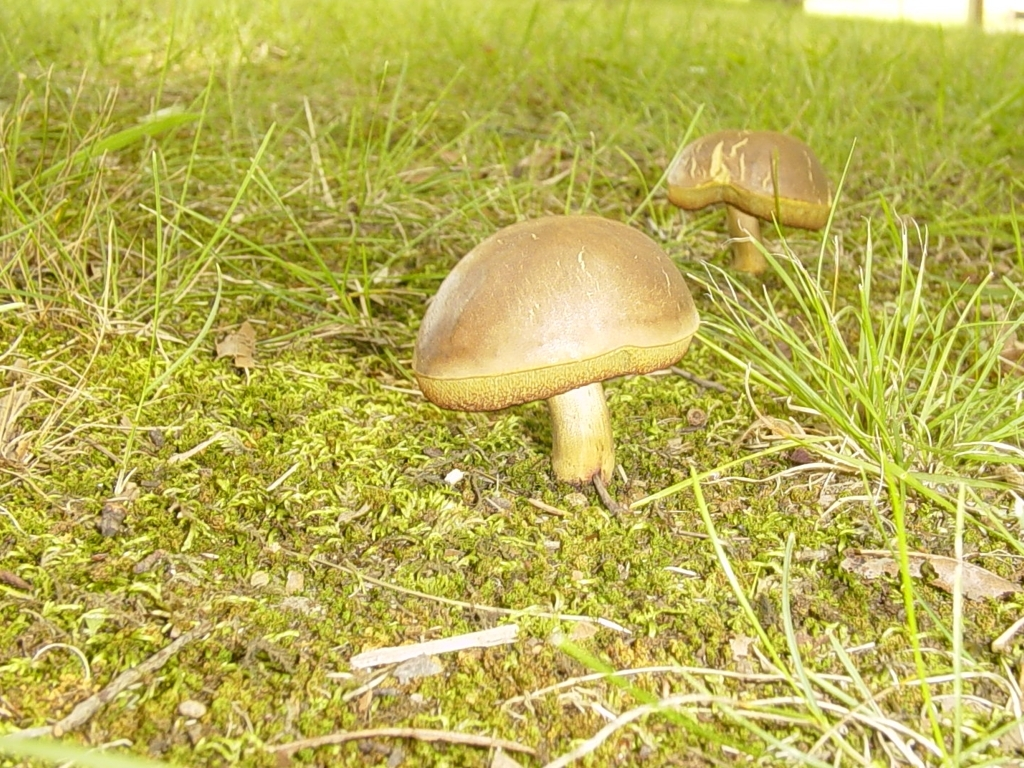What type of mushrooms are these, and are they edible? Without more specific information, it's challenging to accurately identify the type of mushrooms just from an image, as there are thousands of species with similar features. It's important to note that one should never consume wild mushrooms without proper identification by an expert, as many can be poisonous. 